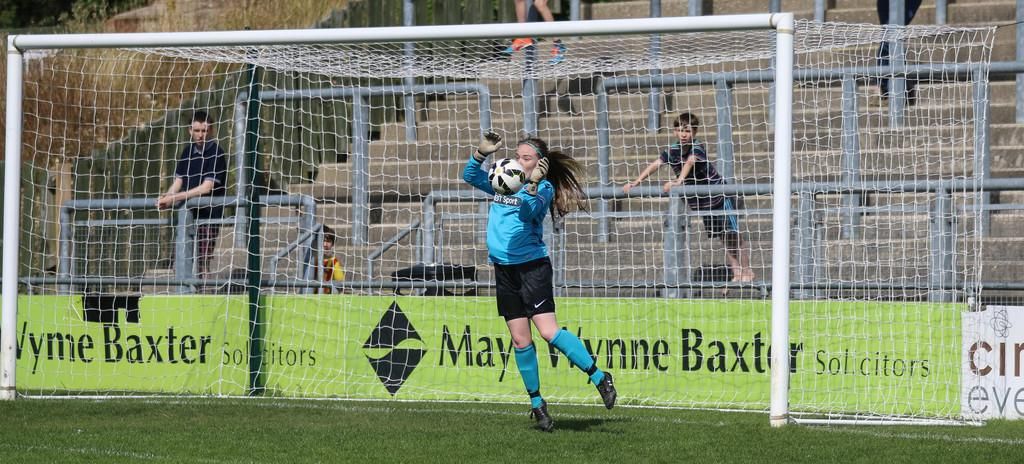<image>
Write a terse but informative summary of the picture. A soccer player in front of a goal post with a Baxter ad nearby. 